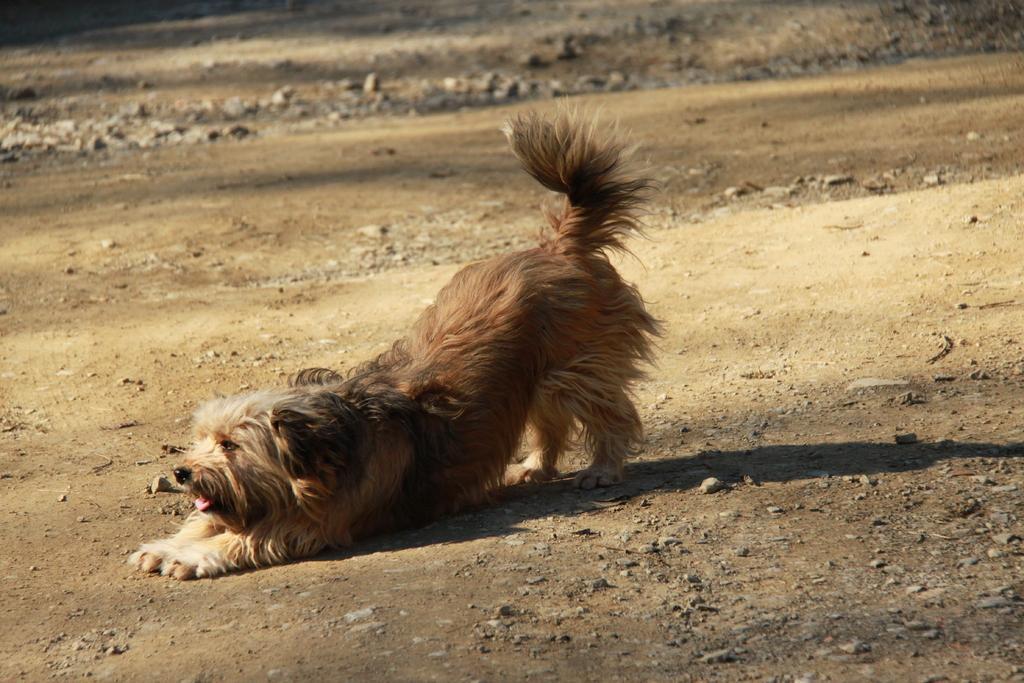Could you give a brief overview of what you see in this image? In the center of the image can see a dog and there are stones. 